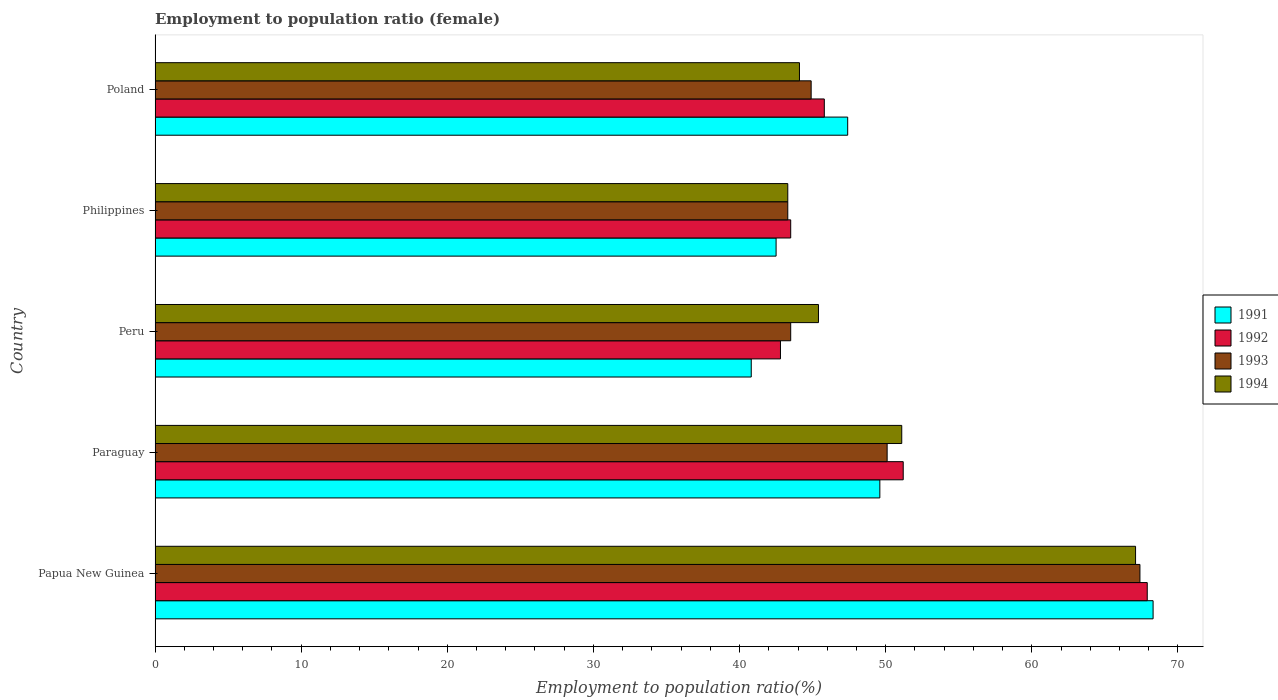How many different coloured bars are there?
Provide a succinct answer. 4. Are the number of bars per tick equal to the number of legend labels?
Your answer should be very brief. Yes. Are the number of bars on each tick of the Y-axis equal?
Ensure brevity in your answer.  Yes. How many bars are there on the 1st tick from the top?
Your response must be concise. 4. What is the label of the 3rd group of bars from the top?
Offer a very short reply. Peru. In how many cases, is the number of bars for a given country not equal to the number of legend labels?
Your response must be concise. 0. What is the employment to population ratio in 1994 in Papua New Guinea?
Give a very brief answer. 67.1. Across all countries, what is the maximum employment to population ratio in 1992?
Your answer should be compact. 67.9. Across all countries, what is the minimum employment to population ratio in 1994?
Ensure brevity in your answer.  43.3. In which country was the employment to population ratio in 1991 maximum?
Make the answer very short. Papua New Guinea. What is the total employment to population ratio in 1991 in the graph?
Your answer should be very brief. 248.6. What is the difference between the employment to population ratio in 1992 in Papua New Guinea and that in Paraguay?
Your response must be concise. 16.7. What is the difference between the employment to population ratio in 1992 in Philippines and the employment to population ratio in 1994 in Peru?
Offer a terse response. -1.9. What is the average employment to population ratio in 1994 per country?
Keep it short and to the point. 50.2. What is the difference between the employment to population ratio in 1991 and employment to population ratio in 1994 in Paraguay?
Your answer should be very brief. -1.5. What is the ratio of the employment to population ratio in 1993 in Papua New Guinea to that in Poland?
Ensure brevity in your answer.  1.5. Is the difference between the employment to population ratio in 1991 in Peru and Poland greater than the difference between the employment to population ratio in 1994 in Peru and Poland?
Provide a succinct answer. No. What is the difference between the highest and the second highest employment to population ratio in 1992?
Offer a terse response. 16.7. What is the difference between the highest and the lowest employment to population ratio in 1993?
Keep it short and to the point. 24.1. Is it the case that in every country, the sum of the employment to population ratio in 1994 and employment to population ratio in 1992 is greater than the sum of employment to population ratio in 1993 and employment to population ratio in 1991?
Your answer should be very brief. No. Does the graph contain any zero values?
Your answer should be very brief. No. Does the graph contain grids?
Offer a terse response. No. How are the legend labels stacked?
Give a very brief answer. Vertical. What is the title of the graph?
Your answer should be very brief. Employment to population ratio (female). What is the label or title of the X-axis?
Your answer should be very brief. Employment to population ratio(%). What is the label or title of the Y-axis?
Make the answer very short. Country. What is the Employment to population ratio(%) in 1991 in Papua New Guinea?
Give a very brief answer. 68.3. What is the Employment to population ratio(%) in 1992 in Papua New Guinea?
Your answer should be compact. 67.9. What is the Employment to population ratio(%) in 1993 in Papua New Guinea?
Give a very brief answer. 67.4. What is the Employment to population ratio(%) of 1994 in Papua New Guinea?
Give a very brief answer. 67.1. What is the Employment to population ratio(%) of 1991 in Paraguay?
Provide a short and direct response. 49.6. What is the Employment to population ratio(%) of 1992 in Paraguay?
Make the answer very short. 51.2. What is the Employment to population ratio(%) of 1993 in Paraguay?
Ensure brevity in your answer.  50.1. What is the Employment to population ratio(%) of 1994 in Paraguay?
Offer a terse response. 51.1. What is the Employment to population ratio(%) of 1991 in Peru?
Offer a very short reply. 40.8. What is the Employment to population ratio(%) of 1992 in Peru?
Your answer should be compact. 42.8. What is the Employment to population ratio(%) of 1993 in Peru?
Your answer should be compact. 43.5. What is the Employment to population ratio(%) of 1994 in Peru?
Your answer should be compact. 45.4. What is the Employment to population ratio(%) in 1991 in Philippines?
Offer a very short reply. 42.5. What is the Employment to population ratio(%) in 1992 in Philippines?
Make the answer very short. 43.5. What is the Employment to population ratio(%) in 1993 in Philippines?
Offer a very short reply. 43.3. What is the Employment to population ratio(%) in 1994 in Philippines?
Your response must be concise. 43.3. What is the Employment to population ratio(%) in 1991 in Poland?
Provide a short and direct response. 47.4. What is the Employment to population ratio(%) of 1992 in Poland?
Ensure brevity in your answer.  45.8. What is the Employment to population ratio(%) in 1993 in Poland?
Provide a short and direct response. 44.9. What is the Employment to population ratio(%) of 1994 in Poland?
Your answer should be very brief. 44.1. Across all countries, what is the maximum Employment to population ratio(%) of 1991?
Provide a short and direct response. 68.3. Across all countries, what is the maximum Employment to population ratio(%) of 1992?
Provide a succinct answer. 67.9. Across all countries, what is the maximum Employment to population ratio(%) in 1993?
Make the answer very short. 67.4. Across all countries, what is the maximum Employment to population ratio(%) of 1994?
Make the answer very short. 67.1. Across all countries, what is the minimum Employment to population ratio(%) of 1991?
Offer a very short reply. 40.8. Across all countries, what is the minimum Employment to population ratio(%) of 1992?
Keep it short and to the point. 42.8. Across all countries, what is the minimum Employment to population ratio(%) in 1993?
Your response must be concise. 43.3. Across all countries, what is the minimum Employment to population ratio(%) in 1994?
Your response must be concise. 43.3. What is the total Employment to population ratio(%) in 1991 in the graph?
Offer a very short reply. 248.6. What is the total Employment to population ratio(%) in 1992 in the graph?
Ensure brevity in your answer.  251.2. What is the total Employment to population ratio(%) in 1993 in the graph?
Provide a short and direct response. 249.2. What is the total Employment to population ratio(%) in 1994 in the graph?
Provide a short and direct response. 251. What is the difference between the Employment to population ratio(%) of 1991 in Papua New Guinea and that in Paraguay?
Provide a short and direct response. 18.7. What is the difference between the Employment to population ratio(%) in 1994 in Papua New Guinea and that in Paraguay?
Ensure brevity in your answer.  16. What is the difference between the Employment to population ratio(%) in 1992 in Papua New Guinea and that in Peru?
Keep it short and to the point. 25.1. What is the difference between the Employment to population ratio(%) of 1993 in Papua New Guinea and that in Peru?
Provide a short and direct response. 23.9. What is the difference between the Employment to population ratio(%) in 1994 in Papua New Guinea and that in Peru?
Give a very brief answer. 21.7. What is the difference between the Employment to population ratio(%) of 1991 in Papua New Guinea and that in Philippines?
Your response must be concise. 25.8. What is the difference between the Employment to population ratio(%) of 1992 in Papua New Guinea and that in Philippines?
Make the answer very short. 24.4. What is the difference between the Employment to population ratio(%) of 1993 in Papua New Guinea and that in Philippines?
Provide a succinct answer. 24.1. What is the difference between the Employment to population ratio(%) of 1994 in Papua New Guinea and that in Philippines?
Keep it short and to the point. 23.8. What is the difference between the Employment to population ratio(%) in 1991 in Papua New Guinea and that in Poland?
Offer a terse response. 20.9. What is the difference between the Employment to population ratio(%) of 1992 in Papua New Guinea and that in Poland?
Ensure brevity in your answer.  22.1. What is the difference between the Employment to population ratio(%) in 1993 in Papua New Guinea and that in Poland?
Your answer should be very brief. 22.5. What is the difference between the Employment to population ratio(%) in 1994 in Paraguay and that in Philippines?
Offer a terse response. 7.8. What is the difference between the Employment to population ratio(%) in 1991 in Paraguay and that in Poland?
Provide a short and direct response. 2.2. What is the difference between the Employment to population ratio(%) in 1992 in Paraguay and that in Poland?
Provide a succinct answer. 5.4. What is the difference between the Employment to population ratio(%) of 1994 in Paraguay and that in Poland?
Offer a very short reply. 7. What is the difference between the Employment to population ratio(%) of 1991 in Peru and that in Philippines?
Offer a terse response. -1.7. What is the difference between the Employment to population ratio(%) of 1992 in Peru and that in Philippines?
Your answer should be compact. -0.7. What is the difference between the Employment to population ratio(%) of 1994 in Peru and that in Philippines?
Provide a succinct answer. 2.1. What is the difference between the Employment to population ratio(%) in 1994 in Peru and that in Poland?
Offer a terse response. 1.3. What is the difference between the Employment to population ratio(%) in 1991 in Philippines and that in Poland?
Give a very brief answer. -4.9. What is the difference between the Employment to population ratio(%) of 1994 in Philippines and that in Poland?
Give a very brief answer. -0.8. What is the difference between the Employment to population ratio(%) of 1991 in Papua New Guinea and the Employment to population ratio(%) of 1992 in Paraguay?
Give a very brief answer. 17.1. What is the difference between the Employment to population ratio(%) of 1992 in Papua New Guinea and the Employment to population ratio(%) of 1993 in Paraguay?
Provide a short and direct response. 17.8. What is the difference between the Employment to population ratio(%) of 1993 in Papua New Guinea and the Employment to population ratio(%) of 1994 in Paraguay?
Your response must be concise. 16.3. What is the difference between the Employment to population ratio(%) of 1991 in Papua New Guinea and the Employment to population ratio(%) of 1993 in Peru?
Your response must be concise. 24.8. What is the difference between the Employment to population ratio(%) of 1991 in Papua New Guinea and the Employment to population ratio(%) of 1994 in Peru?
Offer a very short reply. 22.9. What is the difference between the Employment to population ratio(%) of 1992 in Papua New Guinea and the Employment to population ratio(%) of 1993 in Peru?
Provide a short and direct response. 24.4. What is the difference between the Employment to population ratio(%) in 1993 in Papua New Guinea and the Employment to population ratio(%) in 1994 in Peru?
Your answer should be compact. 22. What is the difference between the Employment to population ratio(%) in 1991 in Papua New Guinea and the Employment to population ratio(%) in 1992 in Philippines?
Offer a terse response. 24.8. What is the difference between the Employment to population ratio(%) of 1991 in Papua New Guinea and the Employment to population ratio(%) of 1993 in Philippines?
Offer a terse response. 25. What is the difference between the Employment to population ratio(%) in 1992 in Papua New Guinea and the Employment to population ratio(%) in 1993 in Philippines?
Your answer should be very brief. 24.6. What is the difference between the Employment to population ratio(%) of 1992 in Papua New Guinea and the Employment to population ratio(%) of 1994 in Philippines?
Ensure brevity in your answer.  24.6. What is the difference between the Employment to population ratio(%) of 1993 in Papua New Guinea and the Employment to population ratio(%) of 1994 in Philippines?
Ensure brevity in your answer.  24.1. What is the difference between the Employment to population ratio(%) of 1991 in Papua New Guinea and the Employment to population ratio(%) of 1992 in Poland?
Offer a terse response. 22.5. What is the difference between the Employment to population ratio(%) in 1991 in Papua New Guinea and the Employment to population ratio(%) in 1993 in Poland?
Make the answer very short. 23.4. What is the difference between the Employment to population ratio(%) of 1991 in Papua New Guinea and the Employment to population ratio(%) of 1994 in Poland?
Your answer should be compact. 24.2. What is the difference between the Employment to population ratio(%) of 1992 in Papua New Guinea and the Employment to population ratio(%) of 1994 in Poland?
Your answer should be compact. 23.8. What is the difference between the Employment to population ratio(%) of 1993 in Papua New Guinea and the Employment to population ratio(%) of 1994 in Poland?
Give a very brief answer. 23.3. What is the difference between the Employment to population ratio(%) of 1991 in Paraguay and the Employment to population ratio(%) of 1992 in Peru?
Provide a short and direct response. 6.8. What is the difference between the Employment to population ratio(%) of 1992 in Paraguay and the Employment to population ratio(%) of 1993 in Peru?
Make the answer very short. 7.7. What is the difference between the Employment to population ratio(%) in 1991 in Paraguay and the Employment to population ratio(%) in 1993 in Philippines?
Provide a short and direct response. 6.3. What is the difference between the Employment to population ratio(%) of 1991 in Paraguay and the Employment to population ratio(%) of 1994 in Philippines?
Make the answer very short. 6.3. What is the difference between the Employment to population ratio(%) of 1992 in Paraguay and the Employment to population ratio(%) of 1993 in Philippines?
Provide a short and direct response. 7.9. What is the difference between the Employment to population ratio(%) in 1992 in Paraguay and the Employment to population ratio(%) in 1994 in Philippines?
Your response must be concise. 7.9. What is the difference between the Employment to population ratio(%) in 1993 in Paraguay and the Employment to population ratio(%) in 1994 in Philippines?
Your answer should be compact. 6.8. What is the difference between the Employment to population ratio(%) of 1991 in Peru and the Employment to population ratio(%) of 1993 in Philippines?
Your response must be concise. -2.5. What is the difference between the Employment to population ratio(%) of 1991 in Peru and the Employment to population ratio(%) of 1994 in Philippines?
Keep it short and to the point. -2.5. What is the difference between the Employment to population ratio(%) in 1992 in Peru and the Employment to population ratio(%) in 1993 in Philippines?
Provide a short and direct response. -0.5. What is the difference between the Employment to population ratio(%) of 1992 in Peru and the Employment to population ratio(%) of 1994 in Philippines?
Offer a very short reply. -0.5. What is the difference between the Employment to population ratio(%) in 1992 in Peru and the Employment to population ratio(%) in 1994 in Poland?
Provide a succinct answer. -1.3. What is the difference between the Employment to population ratio(%) of 1991 in Philippines and the Employment to population ratio(%) of 1992 in Poland?
Your answer should be compact. -3.3. What is the difference between the Employment to population ratio(%) in 1992 in Philippines and the Employment to population ratio(%) in 1994 in Poland?
Your answer should be very brief. -0.6. What is the difference between the Employment to population ratio(%) in 1993 in Philippines and the Employment to population ratio(%) in 1994 in Poland?
Offer a very short reply. -0.8. What is the average Employment to population ratio(%) of 1991 per country?
Offer a terse response. 49.72. What is the average Employment to population ratio(%) in 1992 per country?
Your answer should be very brief. 50.24. What is the average Employment to population ratio(%) of 1993 per country?
Make the answer very short. 49.84. What is the average Employment to population ratio(%) of 1994 per country?
Offer a very short reply. 50.2. What is the difference between the Employment to population ratio(%) in 1991 and Employment to population ratio(%) in 1993 in Papua New Guinea?
Your response must be concise. 0.9. What is the difference between the Employment to population ratio(%) in 1992 and Employment to population ratio(%) in 1993 in Papua New Guinea?
Provide a short and direct response. 0.5. What is the difference between the Employment to population ratio(%) in 1991 and Employment to population ratio(%) in 1994 in Paraguay?
Your answer should be compact. -1.5. What is the difference between the Employment to population ratio(%) of 1992 and Employment to population ratio(%) of 1993 in Paraguay?
Provide a succinct answer. 1.1. What is the difference between the Employment to population ratio(%) of 1992 and Employment to population ratio(%) of 1994 in Paraguay?
Make the answer very short. 0.1. What is the difference between the Employment to population ratio(%) in 1993 and Employment to population ratio(%) in 1994 in Paraguay?
Keep it short and to the point. -1. What is the difference between the Employment to population ratio(%) in 1992 and Employment to population ratio(%) in 1994 in Peru?
Ensure brevity in your answer.  -2.6. What is the difference between the Employment to population ratio(%) in 1993 and Employment to population ratio(%) in 1994 in Peru?
Your response must be concise. -1.9. What is the difference between the Employment to population ratio(%) in 1991 and Employment to population ratio(%) in 1992 in Philippines?
Keep it short and to the point. -1. What is the difference between the Employment to population ratio(%) in 1992 and Employment to population ratio(%) in 1993 in Philippines?
Offer a very short reply. 0.2. What is the difference between the Employment to population ratio(%) of 1992 and Employment to population ratio(%) of 1994 in Philippines?
Keep it short and to the point. 0.2. What is the difference between the Employment to population ratio(%) of 1993 and Employment to population ratio(%) of 1994 in Philippines?
Provide a succinct answer. 0. What is the difference between the Employment to population ratio(%) in 1991 and Employment to population ratio(%) in 1993 in Poland?
Offer a very short reply. 2.5. What is the difference between the Employment to population ratio(%) in 1992 and Employment to population ratio(%) in 1993 in Poland?
Provide a short and direct response. 0.9. What is the difference between the Employment to population ratio(%) of 1992 and Employment to population ratio(%) of 1994 in Poland?
Your response must be concise. 1.7. What is the difference between the Employment to population ratio(%) in 1993 and Employment to population ratio(%) in 1994 in Poland?
Keep it short and to the point. 0.8. What is the ratio of the Employment to population ratio(%) in 1991 in Papua New Guinea to that in Paraguay?
Give a very brief answer. 1.38. What is the ratio of the Employment to population ratio(%) in 1992 in Papua New Guinea to that in Paraguay?
Your answer should be very brief. 1.33. What is the ratio of the Employment to population ratio(%) in 1993 in Papua New Guinea to that in Paraguay?
Your answer should be compact. 1.35. What is the ratio of the Employment to population ratio(%) of 1994 in Papua New Guinea to that in Paraguay?
Ensure brevity in your answer.  1.31. What is the ratio of the Employment to population ratio(%) in 1991 in Papua New Guinea to that in Peru?
Your response must be concise. 1.67. What is the ratio of the Employment to population ratio(%) of 1992 in Papua New Guinea to that in Peru?
Provide a succinct answer. 1.59. What is the ratio of the Employment to population ratio(%) in 1993 in Papua New Guinea to that in Peru?
Offer a very short reply. 1.55. What is the ratio of the Employment to population ratio(%) in 1994 in Papua New Guinea to that in Peru?
Give a very brief answer. 1.48. What is the ratio of the Employment to population ratio(%) in 1991 in Papua New Guinea to that in Philippines?
Your response must be concise. 1.61. What is the ratio of the Employment to population ratio(%) of 1992 in Papua New Guinea to that in Philippines?
Offer a very short reply. 1.56. What is the ratio of the Employment to population ratio(%) of 1993 in Papua New Guinea to that in Philippines?
Give a very brief answer. 1.56. What is the ratio of the Employment to population ratio(%) in 1994 in Papua New Guinea to that in Philippines?
Ensure brevity in your answer.  1.55. What is the ratio of the Employment to population ratio(%) of 1991 in Papua New Guinea to that in Poland?
Offer a very short reply. 1.44. What is the ratio of the Employment to population ratio(%) of 1992 in Papua New Guinea to that in Poland?
Ensure brevity in your answer.  1.48. What is the ratio of the Employment to population ratio(%) in 1993 in Papua New Guinea to that in Poland?
Your answer should be compact. 1.5. What is the ratio of the Employment to population ratio(%) in 1994 in Papua New Guinea to that in Poland?
Your answer should be compact. 1.52. What is the ratio of the Employment to population ratio(%) of 1991 in Paraguay to that in Peru?
Keep it short and to the point. 1.22. What is the ratio of the Employment to population ratio(%) of 1992 in Paraguay to that in Peru?
Provide a short and direct response. 1.2. What is the ratio of the Employment to population ratio(%) in 1993 in Paraguay to that in Peru?
Your response must be concise. 1.15. What is the ratio of the Employment to population ratio(%) in 1994 in Paraguay to that in Peru?
Your answer should be compact. 1.13. What is the ratio of the Employment to population ratio(%) in 1991 in Paraguay to that in Philippines?
Make the answer very short. 1.17. What is the ratio of the Employment to population ratio(%) of 1992 in Paraguay to that in Philippines?
Provide a short and direct response. 1.18. What is the ratio of the Employment to population ratio(%) of 1993 in Paraguay to that in Philippines?
Your answer should be very brief. 1.16. What is the ratio of the Employment to population ratio(%) of 1994 in Paraguay to that in Philippines?
Keep it short and to the point. 1.18. What is the ratio of the Employment to population ratio(%) of 1991 in Paraguay to that in Poland?
Give a very brief answer. 1.05. What is the ratio of the Employment to population ratio(%) of 1992 in Paraguay to that in Poland?
Provide a short and direct response. 1.12. What is the ratio of the Employment to population ratio(%) of 1993 in Paraguay to that in Poland?
Your answer should be very brief. 1.12. What is the ratio of the Employment to population ratio(%) of 1994 in Paraguay to that in Poland?
Ensure brevity in your answer.  1.16. What is the ratio of the Employment to population ratio(%) of 1991 in Peru to that in Philippines?
Offer a terse response. 0.96. What is the ratio of the Employment to population ratio(%) of 1992 in Peru to that in Philippines?
Your answer should be compact. 0.98. What is the ratio of the Employment to population ratio(%) of 1994 in Peru to that in Philippines?
Offer a very short reply. 1.05. What is the ratio of the Employment to population ratio(%) in 1991 in Peru to that in Poland?
Make the answer very short. 0.86. What is the ratio of the Employment to population ratio(%) in 1992 in Peru to that in Poland?
Your answer should be compact. 0.93. What is the ratio of the Employment to population ratio(%) in 1993 in Peru to that in Poland?
Ensure brevity in your answer.  0.97. What is the ratio of the Employment to population ratio(%) of 1994 in Peru to that in Poland?
Provide a succinct answer. 1.03. What is the ratio of the Employment to population ratio(%) of 1991 in Philippines to that in Poland?
Provide a short and direct response. 0.9. What is the ratio of the Employment to population ratio(%) in 1992 in Philippines to that in Poland?
Offer a very short reply. 0.95. What is the ratio of the Employment to population ratio(%) of 1993 in Philippines to that in Poland?
Make the answer very short. 0.96. What is the ratio of the Employment to population ratio(%) of 1994 in Philippines to that in Poland?
Make the answer very short. 0.98. What is the difference between the highest and the second highest Employment to population ratio(%) in 1991?
Keep it short and to the point. 18.7. What is the difference between the highest and the second highest Employment to population ratio(%) in 1992?
Provide a succinct answer. 16.7. What is the difference between the highest and the lowest Employment to population ratio(%) in 1991?
Give a very brief answer. 27.5. What is the difference between the highest and the lowest Employment to population ratio(%) in 1992?
Offer a very short reply. 25.1. What is the difference between the highest and the lowest Employment to population ratio(%) in 1993?
Your response must be concise. 24.1. What is the difference between the highest and the lowest Employment to population ratio(%) in 1994?
Your answer should be very brief. 23.8. 